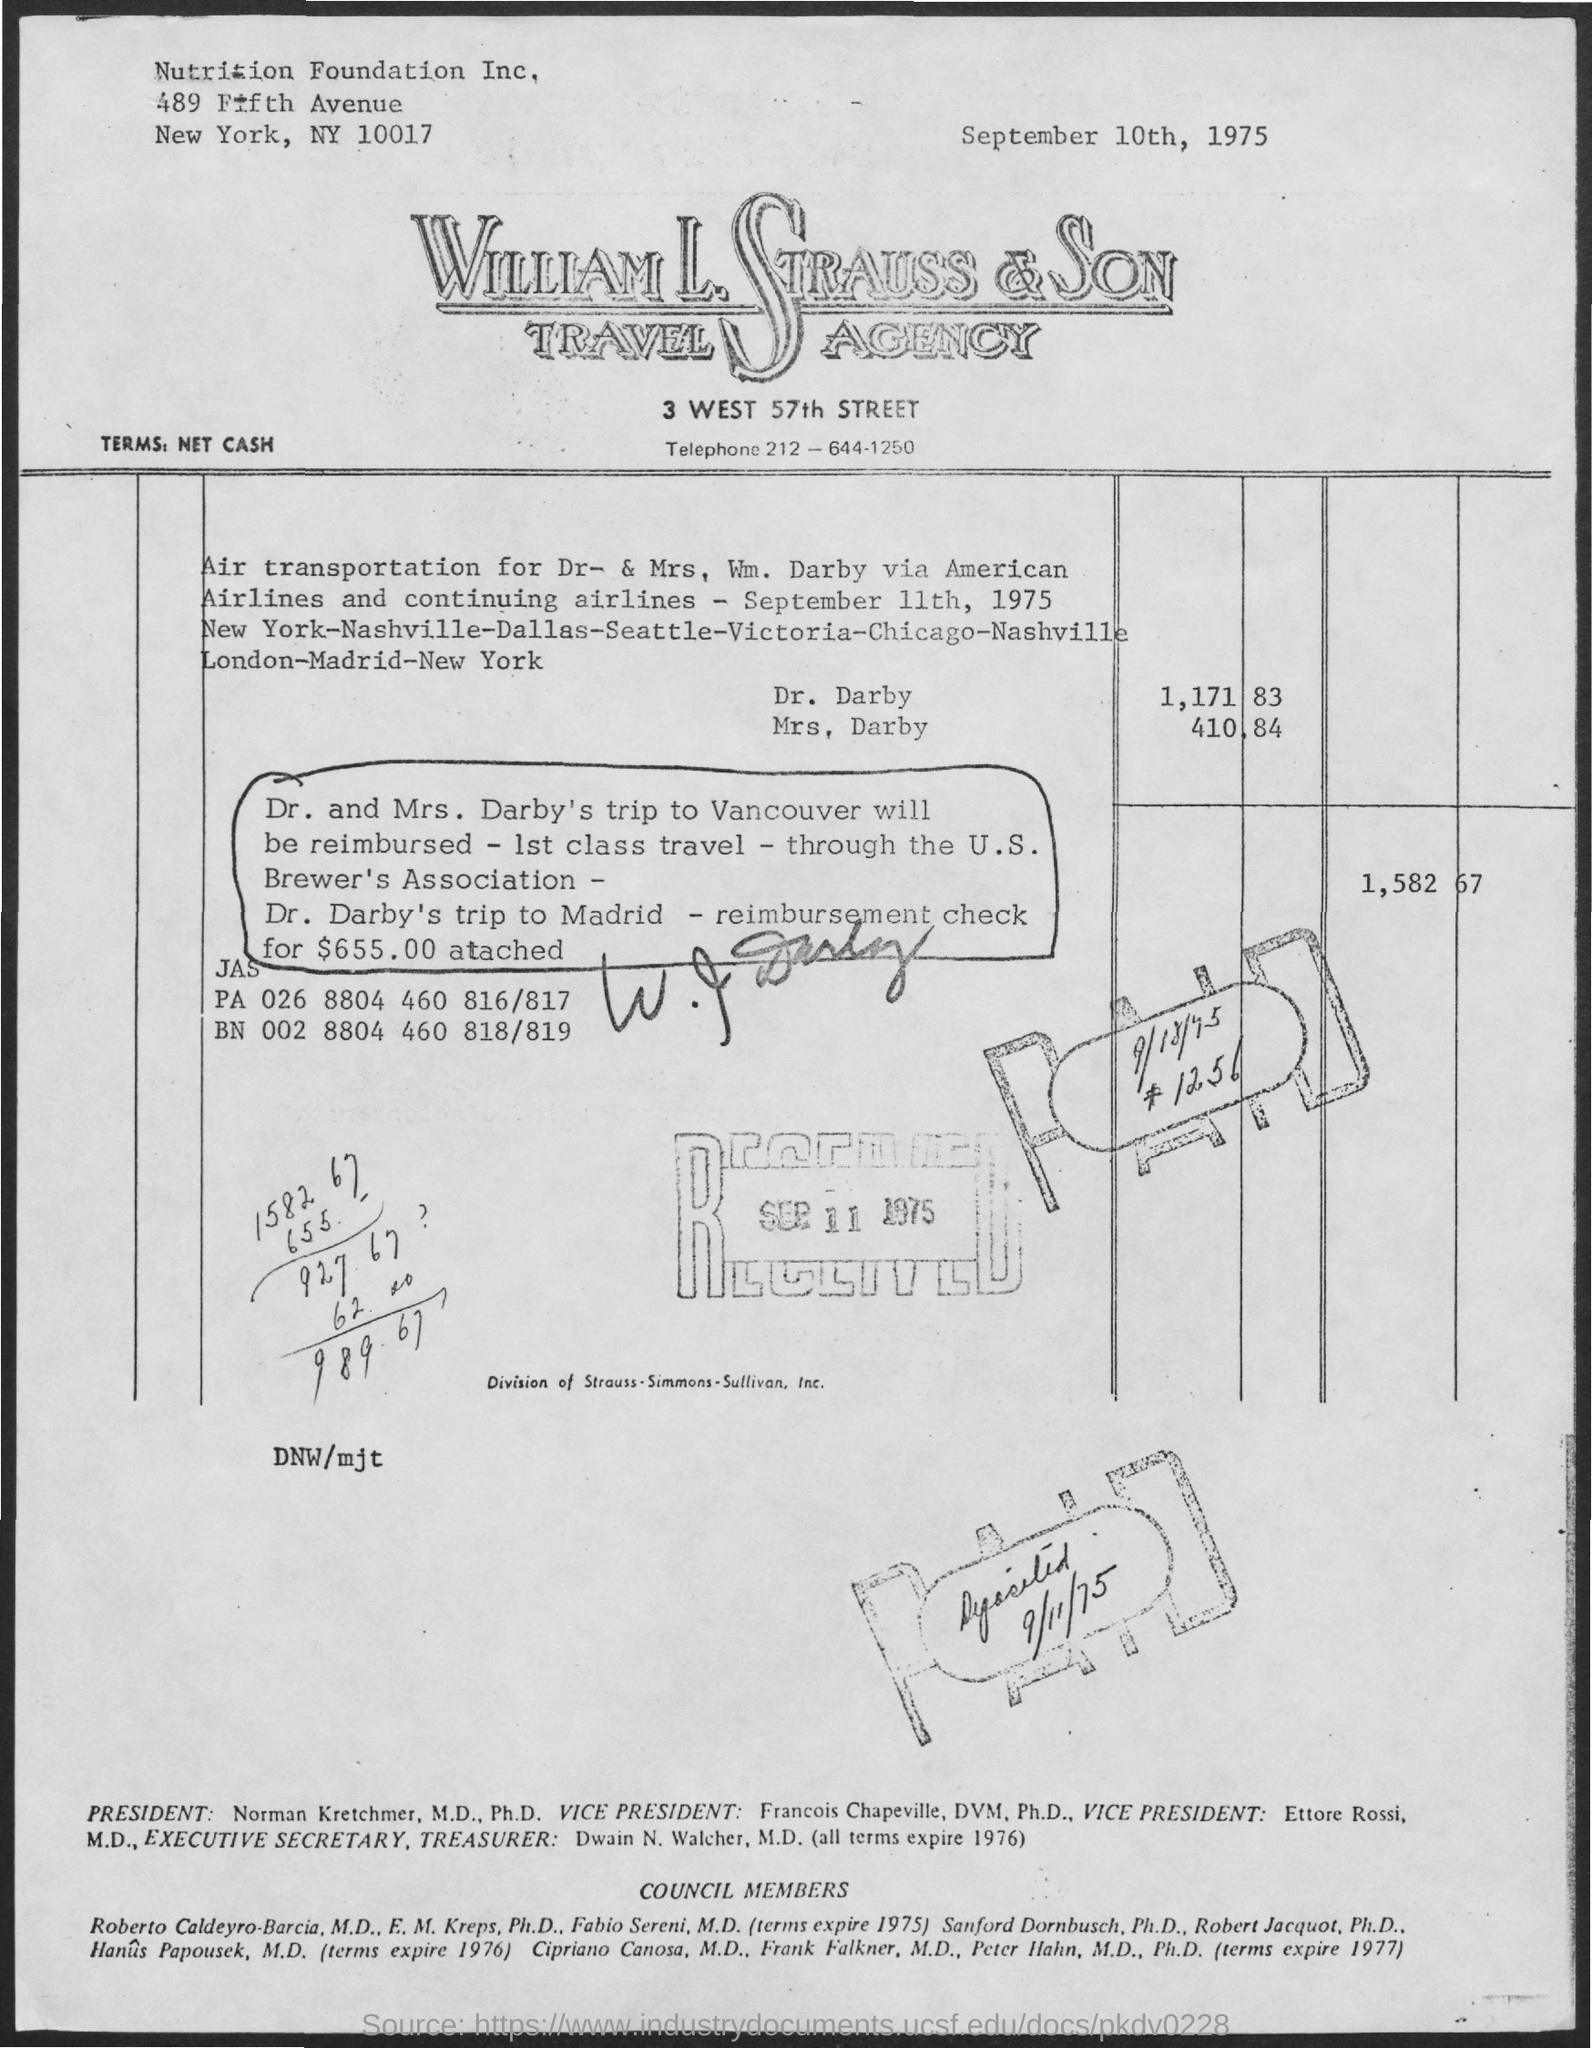Specify some key components in this picture. The postal code of NY is 10017. The date mentioned on the bill at the top is September 10th, 1975. The telephone number of William L. Strauss & Son Travel Agency is 212-644-1250. 